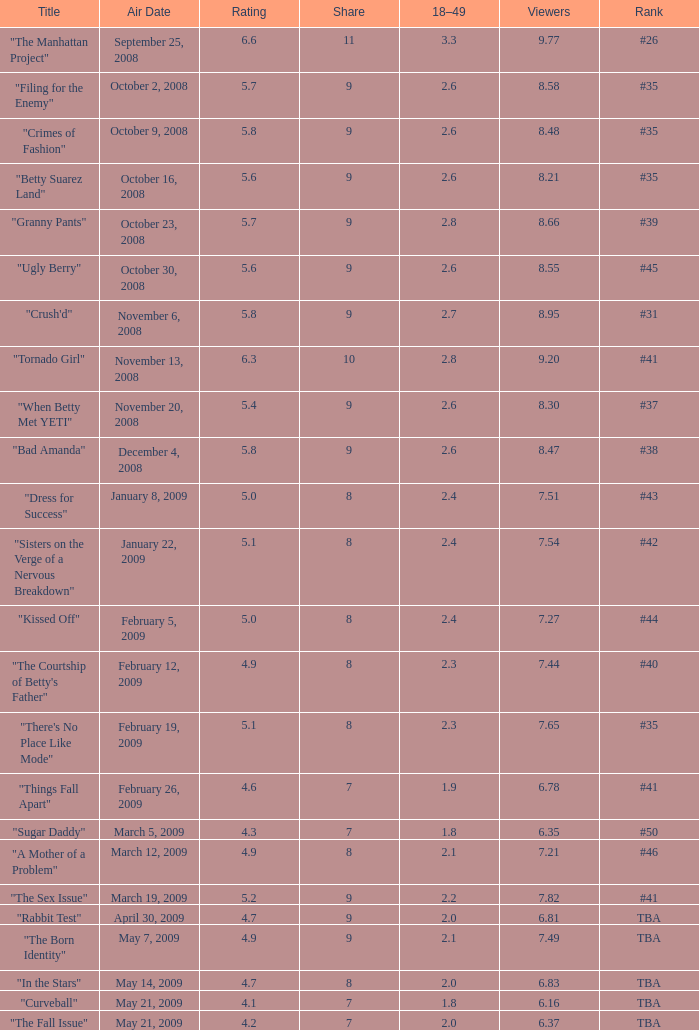What is the lowest Viewers that has an Episode #higher than 58 with a title of "curveball" less than 4.1 rating? None. 